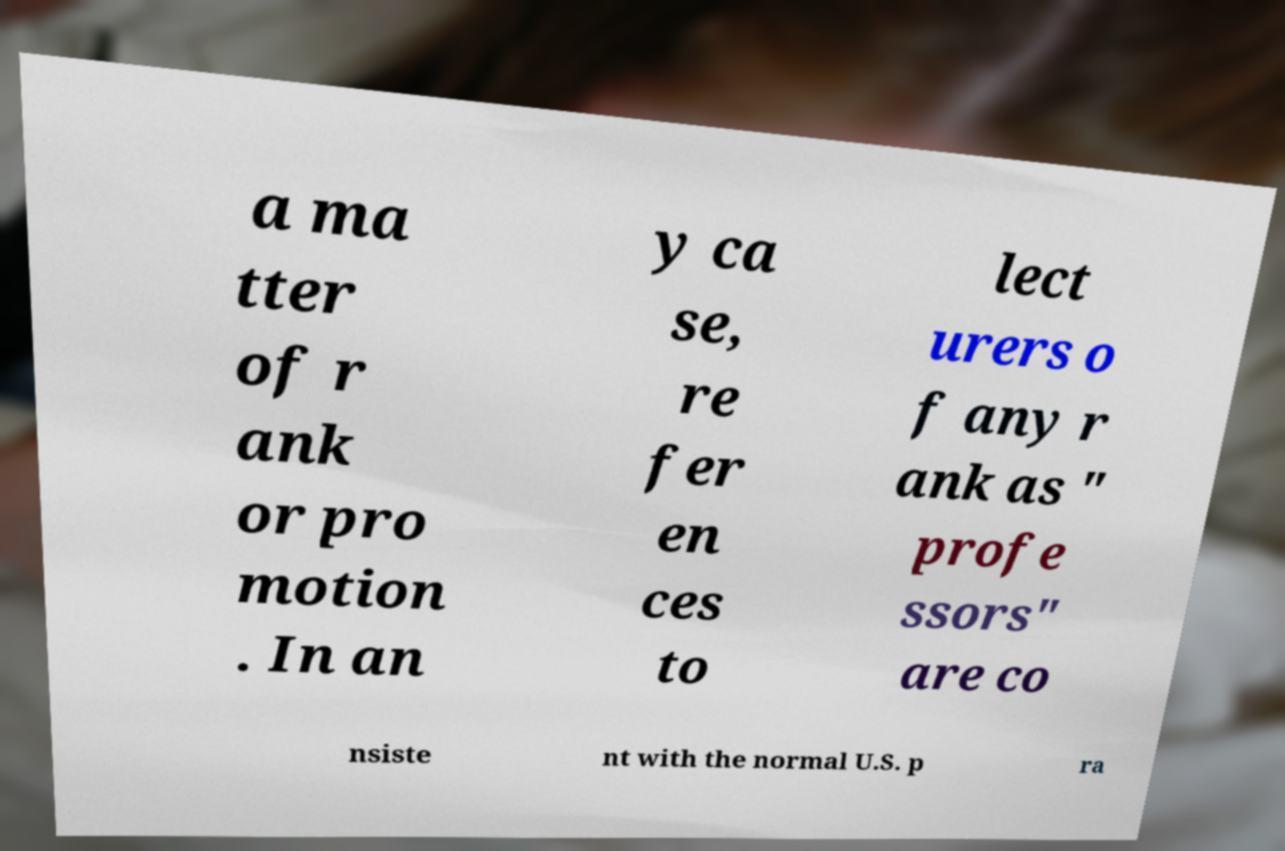Could you assist in decoding the text presented in this image and type it out clearly? a ma tter of r ank or pro motion . In an y ca se, re fer en ces to lect urers o f any r ank as " profe ssors" are co nsiste nt with the normal U.S. p ra 